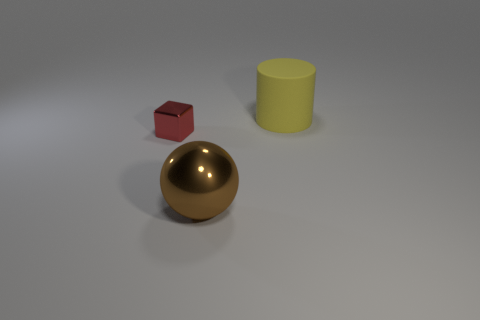There is a matte cylinder; is it the same color as the big thing that is in front of the yellow cylinder?
Make the answer very short. No. Is there any other thing that has the same shape as the large brown metal object?
Your answer should be compact. No. What is the shape of the small red metallic object that is behind the large object in front of the object that is on the left side of the brown metallic ball?
Provide a short and direct response. Cube. The large brown shiny object is what shape?
Make the answer very short. Sphere. There is a big thing in front of the yellow rubber cylinder; what color is it?
Keep it short and to the point. Brown. Does the object that is to the left of the sphere have the same size as the large sphere?
Offer a very short reply. No. Is there any other thing that is the same size as the yellow cylinder?
Offer a very short reply. Yes. Is the brown metallic object the same shape as the small red shiny object?
Keep it short and to the point. No. Are there fewer big matte things left of the brown object than small red blocks to the left of the block?
Your answer should be compact. No. There is a red metallic cube; what number of shiny blocks are behind it?
Ensure brevity in your answer.  0. 